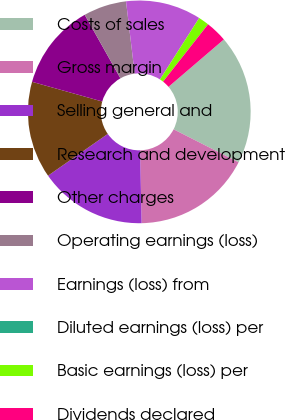Convert chart. <chart><loc_0><loc_0><loc_500><loc_500><pie_chart><fcel>Costs of sales<fcel>Gross margin<fcel>Selling general and<fcel>Research and development<fcel>Other charges<fcel>Operating earnings (loss)<fcel>Earnings (loss) from<fcel>Diluted earnings (loss) per<fcel>Basic earnings (loss) per<fcel>Dividends declared<nl><fcel>18.75%<fcel>17.19%<fcel>15.62%<fcel>14.06%<fcel>12.5%<fcel>6.25%<fcel>10.94%<fcel>0.0%<fcel>1.56%<fcel>3.13%<nl></chart> 